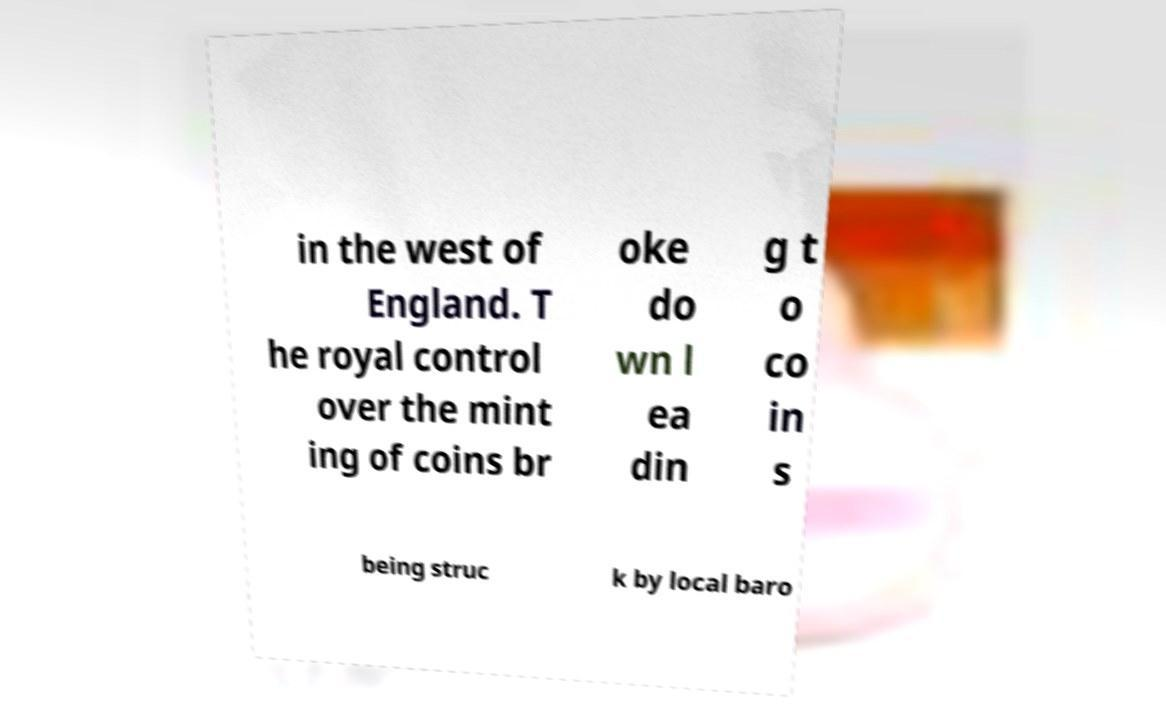Could you extract and type out the text from this image? in the west of England. T he royal control over the mint ing of coins br oke do wn l ea din g t o co in s being struc k by local baro 